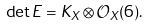<formula> <loc_0><loc_0><loc_500><loc_500>\det E = K _ { X } \otimes \mathcal { O } _ { X } ( 6 ) .</formula> 